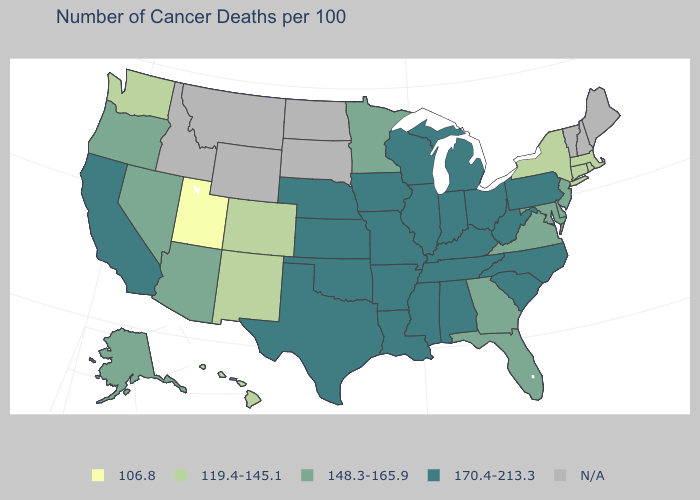Name the states that have a value in the range 106.8?
Keep it brief. Utah. Which states have the highest value in the USA?
Short answer required. Alabama, Arkansas, California, Illinois, Indiana, Iowa, Kansas, Kentucky, Louisiana, Michigan, Mississippi, Missouri, Nebraska, North Carolina, Ohio, Oklahoma, Pennsylvania, South Carolina, Tennessee, Texas, West Virginia, Wisconsin. Does South Carolina have the highest value in the USA?
Answer briefly. Yes. Name the states that have a value in the range 148.3-165.9?
Quick response, please. Alaska, Arizona, Delaware, Florida, Georgia, Maryland, Minnesota, Nevada, New Jersey, Oregon, Virginia. Does the first symbol in the legend represent the smallest category?
Keep it brief. Yes. Name the states that have a value in the range 119.4-145.1?
Concise answer only. Colorado, Connecticut, Hawaii, Massachusetts, New Mexico, New York, Rhode Island, Washington. What is the value of Tennessee?
Concise answer only. 170.4-213.3. Which states have the lowest value in the USA?
Write a very short answer. Utah. What is the value of New Jersey?
Give a very brief answer. 148.3-165.9. What is the lowest value in states that border Maryland?
Write a very short answer. 148.3-165.9. Does the map have missing data?
Write a very short answer. Yes. Does Mississippi have the highest value in the South?
Keep it brief. Yes. What is the value of Wisconsin?
Answer briefly. 170.4-213.3. What is the highest value in states that border Colorado?
Quick response, please. 170.4-213.3. 